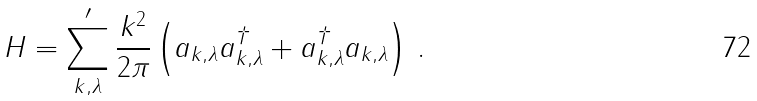Convert formula to latex. <formula><loc_0><loc_0><loc_500><loc_500>H = \sum ^ { \prime } _ { { k } , \lambda } \frac { k ^ { 2 } } { 2 \pi } \left ( a _ { { k } , \lambda } a ^ { \dag } _ { { k } , \lambda } + a ^ { \dag } _ { { k } , \lambda } a _ { { k } , \lambda } \right ) \, .</formula> 